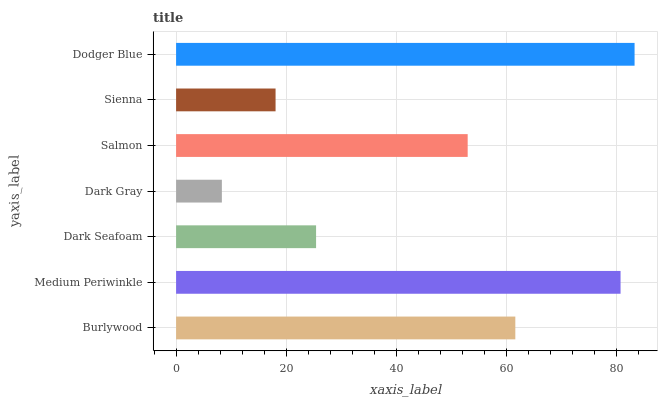Is Dark Gray the minimum?
Answer yes or no. Yes. Is Dodger Blue the maximum?
Answer yes or no. Yes. Is Medium Periwinkle the minimum?
Answer yes or no. No. Is Medium Periwinkle the maximum?
Answer yes or no. No. Is Medium Periwinkle greater than Burlywood?
Answer yes or no. Yes. Is Burlywood less than Medium Periwinkle?
Answer yes or no. Yes. Is Burlywood greater than Medium Periwinkle?
Answer yes or no. No. Is Medium Periwinkle less than Burlywood?
Answer yes or no. No. Is Salmon the high median?
Answer yes or no. Yes. Is Salmon the low median?
Answer yes or no. Yes. Is Sienna the high median?
Answer yes or no. No. Is Dark Gray the low median?
Answer yes or no. No. 